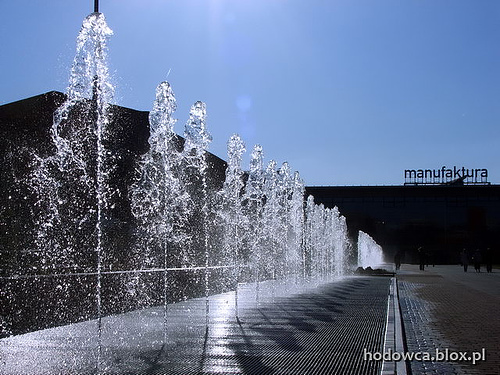<image>
Is the water above the pipe? Yes. The water is positioned above the pipe in the vertical space, higher up in the scene. 